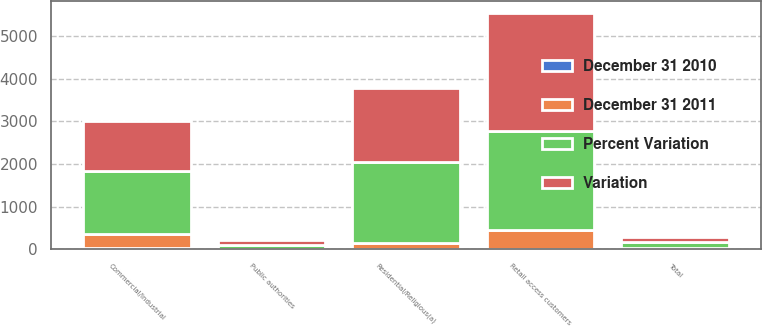<chart> <loc_0><loc_0><loc_500><loc_500><stacked_bar_chart><ecel><fcel>Residential/Religious(a)<fcel>Commercial/Industrial<fcel>Retail access customers<fcel>Public authorities<fcel>Total<nl><fcel>Variation<fcel>1750<fcel>1168<fcel>2760<fcel>111<fcel>127<nl><fcel>Percent Variation<fcel>1893<fcel>1495<fcel>2330<fcel>110<fcel>127<nl><fcel>December 31 2011<fcel>143<fcel>327<fcel>430<fcel>1<fcel>39<nl><fcel>December 31 2010<fcel>7.6<fcel>21.9<fcel>18.5<fcel>0.9<fcel>0.7<nl></chart> 